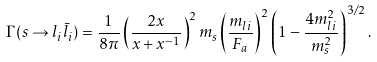<formula> <loc_0><loc_0><loc_500><loc_500>\Gamma ( s \to l _ { i } \bar { l } _ { i } ) = \frac { 1 } { 8 \pi } \left ( \frac { 2 x } { x + x ^ { - 1 } } \right ) ^ { 2 } m _ { s } \left ( \frac { m _ { l i } } { F _ { a } } \right ) ^ { 2 } \left ( 1 - \frac { 4 m _ { l i } ^ { 2 } } { m _ { s } ^ { 2 } } \right ) ^ { 3 / 2 } .</formula> 